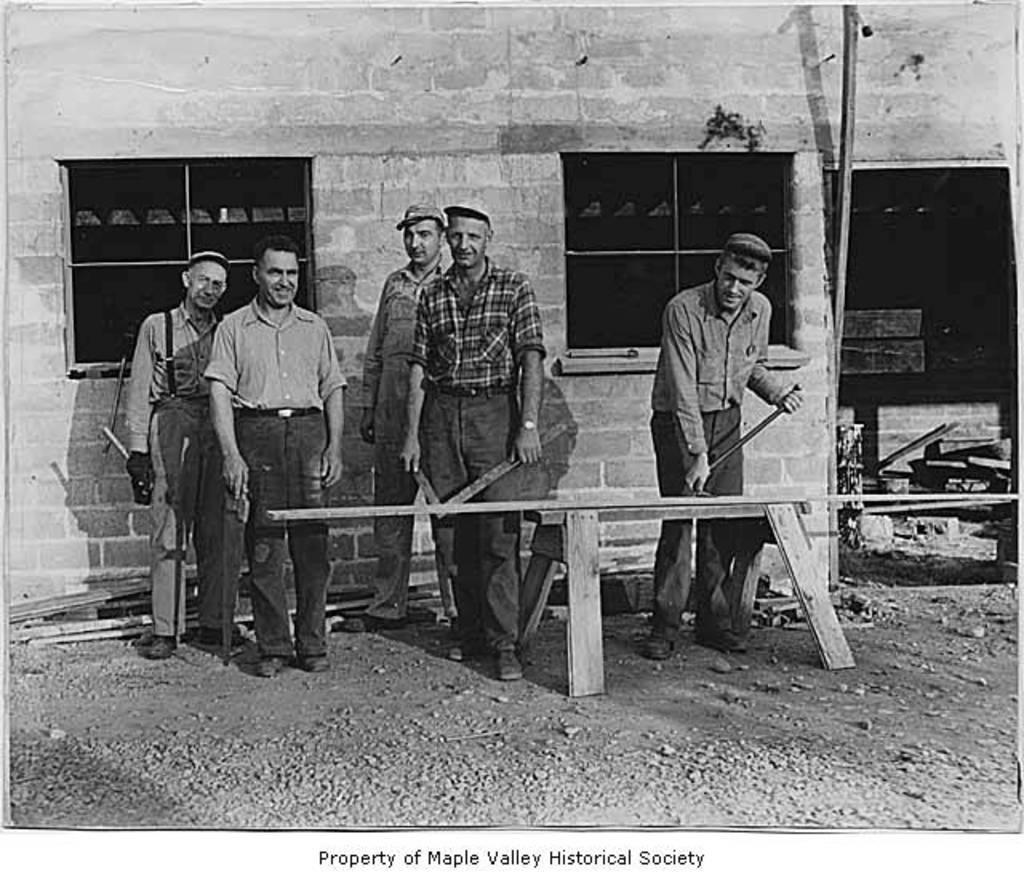Can you describe this image briefly? This is a black and white picture. In the center of the picture there are people, wooden logs and stones. In the foreground there are stones. In the background there is a building under construction. 